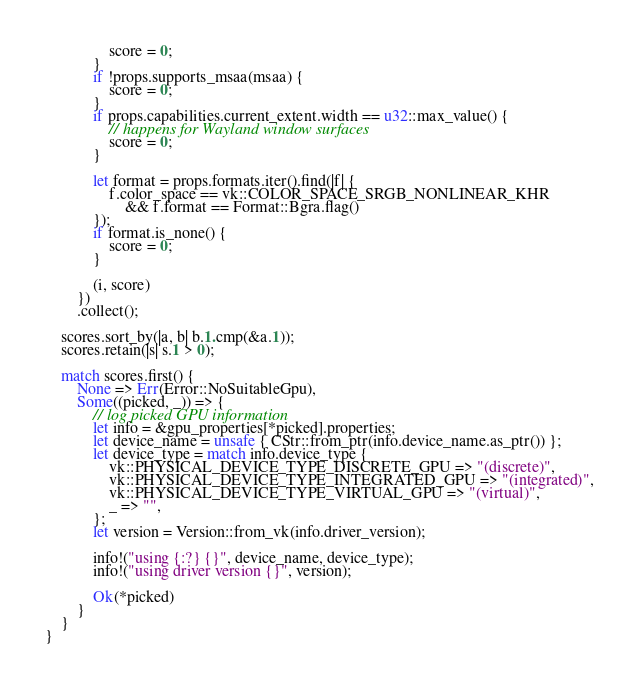Convert code to text. <code><loc_0><loc_0><loc_500><loc_500><_Rust_>                score = 0;
            }
            if !props.supports_msaa(msaa) {
                score = 0;
            }
            if props.capabilities.current_extent.width == u32::max_value() {
                // happens for Wayland window surfaces
                score = 0;
            }

            let format = props.formats.iter().find(|f| {
                f.color_space == vk::COLOR_SPACE_SRGB_NONLINEAR_KHR
                    && f.format == Format::Bgra.flag()
            });
            if format.is_none() {
                score = 0;
            }

            (i, score)
        })
        .collect();

    scores.sort_by(|a, b| b.1.cmp(&a.1));
    scores.retain(|s| s.1 > 0);

    match scores.first() {
        None => Err(Error::NoSuitableGpu),
        Some((picked, _)) => {
            // log picked GPU information
            let info = &gpu_properties[*picked].properties;
            let device_name = unsafe { CStr::from_ptr(info.device_name.as_ptr()) };
            let device_type = match info.device_type {
                vk::PHYSICAL_DEVICE_TYPE_DISCRETE_GPU => "(discrete)",
                vk::PHYSICAL_DEVICE_TYPE_INTEGRATED_GPU => "(integrated)",
                vk::PHYSICAL_DEVICE_TYPE_VIRTUAL_GPU => "(virtual)",
                _ => "",
            };
            let version = Version::from_vk(info.driver_version);

            info!("using {:?} {}", device_name, device_type);
            info!("using driver version {}", version);

            Ok(*picked)
        }
    }
}
</code> 